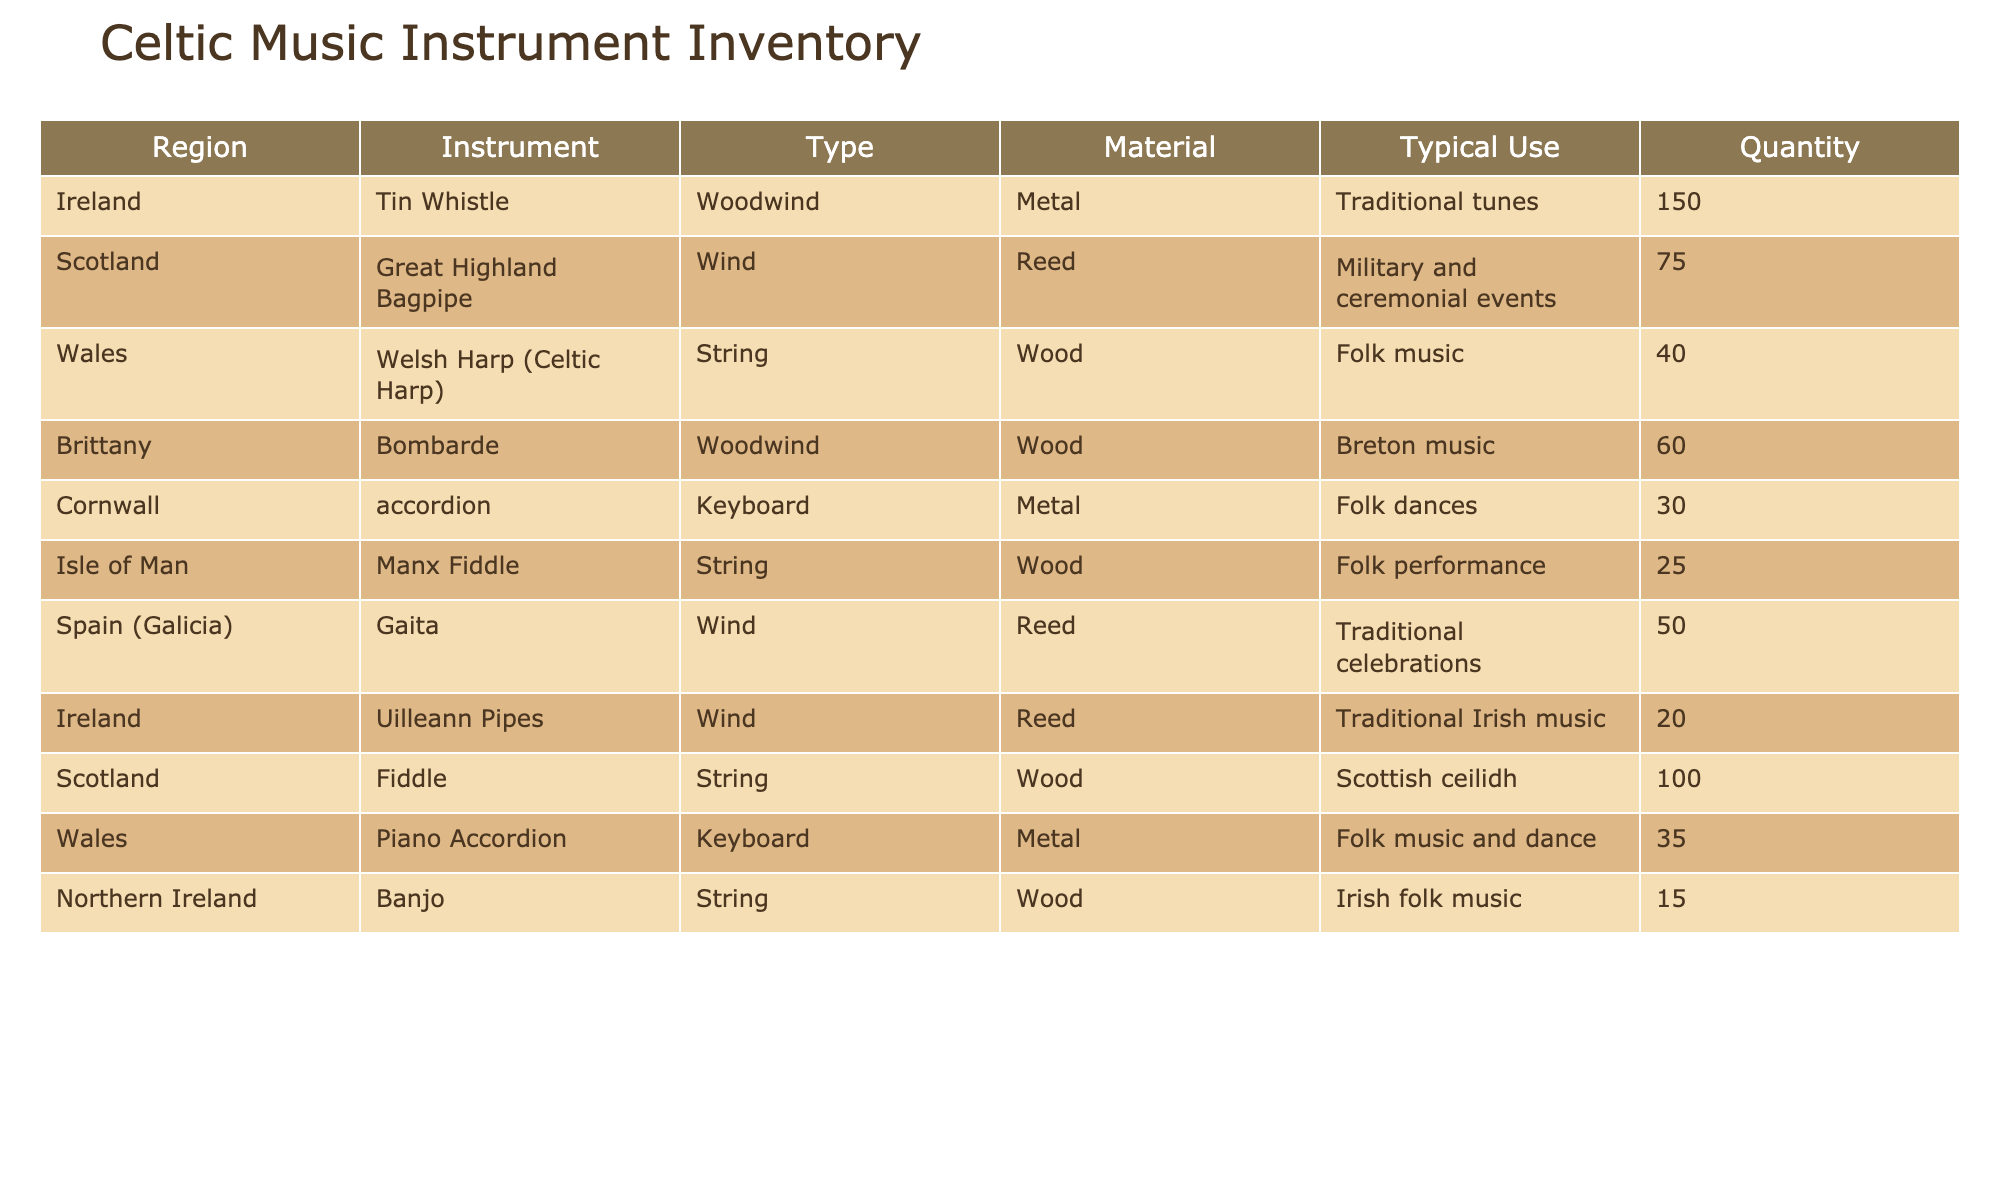What is the total quantity of Tin Whistles in the inventory? The table lists the quantity of Tin Whistles under the "Quantity" column for the region of Ireland. There are 150 Tin Whistles.
Answer: 150 How many different types of instruments are listed in total? By counting the distinct instruments in the "Instrument" column, we find there are a total of 8 different instruments: Tin Whistle, Great Highland Bagpipe, Welsh Harp (Celtic Harp), Bombarde, accordion, Manx Fiddle, Gaita, Uilleann Pipes, Fiddle, Piano Accordion, Banjo.
Answer: 11 Is the Manx Fiddle the only string instrument from the Isle of Man? The table shows that the Manx Fiddle is listed as a string instrument from the Isle of Man. There are no other string instruments mentioned from this region, so yes, it is the only one.
Answer: Yes What is the average quantity of instruments per region? There are 8 regions, and the total quantity of instruments is calculated as: 150 + 75 + 40 + 60 + 30 + 25 + 50 + 20 + 100 + 35 + 15 = 600. Dividing this total by the number of regions (8), we get an average of 600/8 = 75.
Answer: 75 Which region has the highest quantity of instruments in the inventory? By comparing the quantities across all listed regions, Ireland has 150 Tin Whistles, which is greater than any other individual instrument count in the table. Therefore, Ireland has the highest quantity of instruments.
Answer: Ireland What is the total quantity of woodwind instruments? Woodwind instruments listed are the Tin Whistle and Bombarde (Ireland and Brittany), as well as Uilleann Pipes from Ireland. Adding these quantities: 150 (Tin Whistle) + 60 (Bombarde) + 20 (Uilleann Pipes) = 230.
Answer: 230 How many string instruments are listed in total? From the table, the string instruments identified are the Welsh Harp, Manx Fiddle, Fiddle, and Banjo. The total quantities for these instruments are: 40 + 25 + 100 + 15 = 180.
Answer: 180 Does Wales have more quantities of instruments in total compared to Northern Ireland? Wales has a quantity total of 40 (Welsh Harp) + 35 (Piano Accordion) = 75, while Northern Ireland has 15 (Banjo). Thus, Wales has more.
Answer: Yes Which instrument is the most common in the inventory, and what is its quantity? The Tin Whistle has the highest quantity listed in the inventory, with 150 units. Therefore, the most common instrument is the Tin Whistle.
Answer: Tin Whistle, 150 